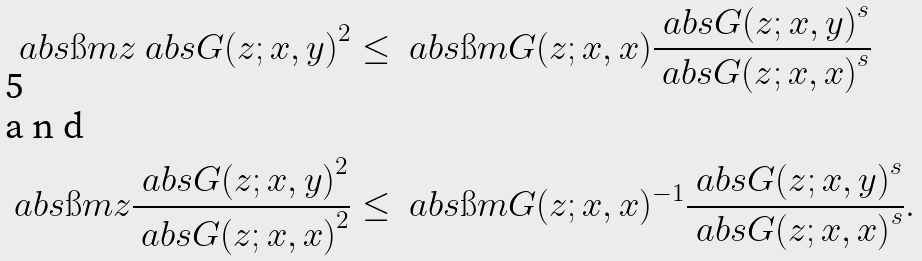<formula> <loc_0><loc_0><loc_500><loc_500>\ a b s { \i m z } \ a b s { G ( z ; x , y ) } ^ { 2 } & \leq \ a b s { \i m G ( z ; x , x ) } \frac { \ a b s { G ( z ; x , y ) } ^ { s } } { \ a b s { G ( z ; x , x ) } ^ { s } } \intertext { a n d } \ a b s { \i m z } \frac { \ a b s { G ( z ; x , y ) } ^ { 2 } } { \ a b s { G ( z ; x , x ) } ^ { 2 } } & \leq \ a b s { \i m G ( z ; x , x ) ^ { - 1 } } \frac { \ a b s { G ( z ; x , y ) } ^ { s } } { \ a b s { G ( z ; x , x ) } ^ { s } } .</formula> 